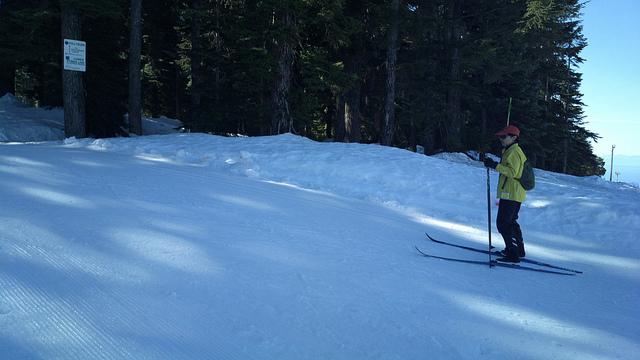Is it snowing?
Quick response, please. No. Is she skiing downhill?
Short answer required. No. Is the skier wearing an appropriate outfit?
Be succinct. Yes. 